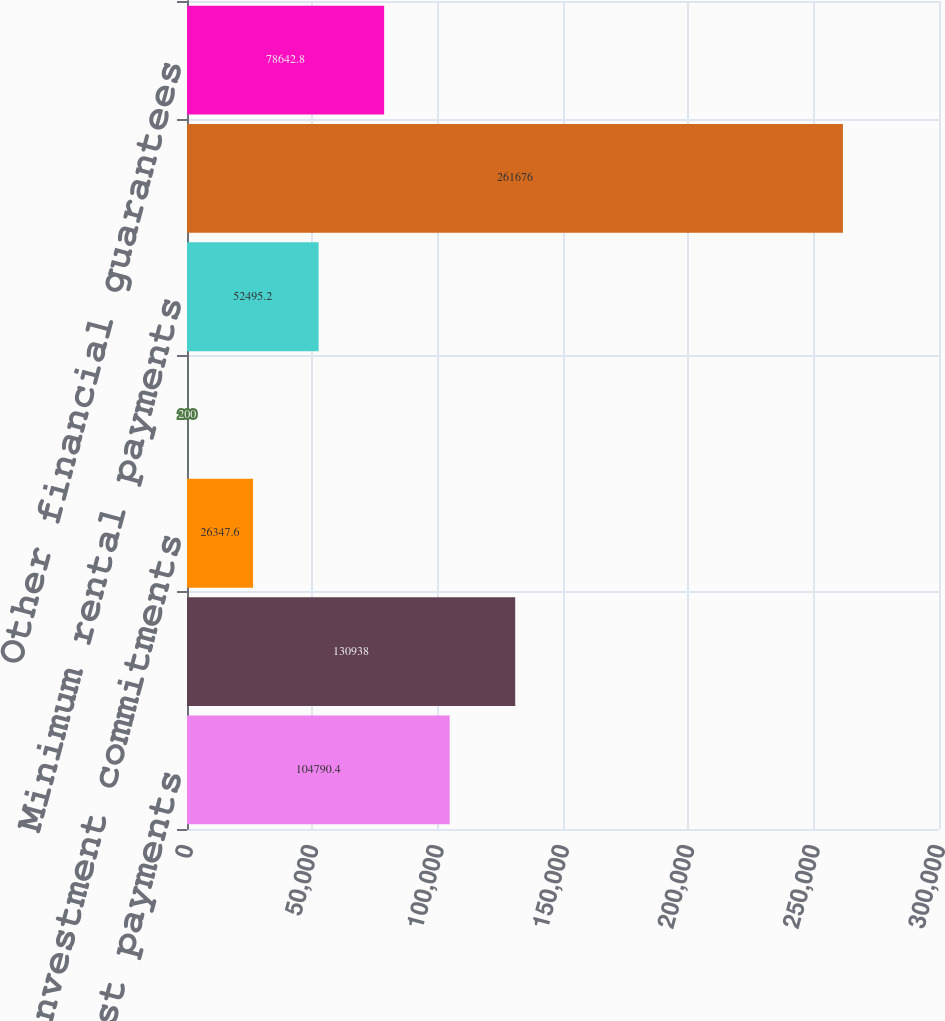<chart> <loc_0><loc_0><loc_500><loc_500><bar_chart><fcel>Contractual interest payments<fcel>Commitments to extend credit<fcel>Investment commitments<fcel>Other commitments<fcel>Minimum rental payments<fcel>Derivative guarantees<fcel>Other financial guarantees<nl><fcel>104790<fcel>130938<fcel>26347.6<fcel>200<fcel>52495.2<fcel>261676<fcel>78642.8<nl></chart> 